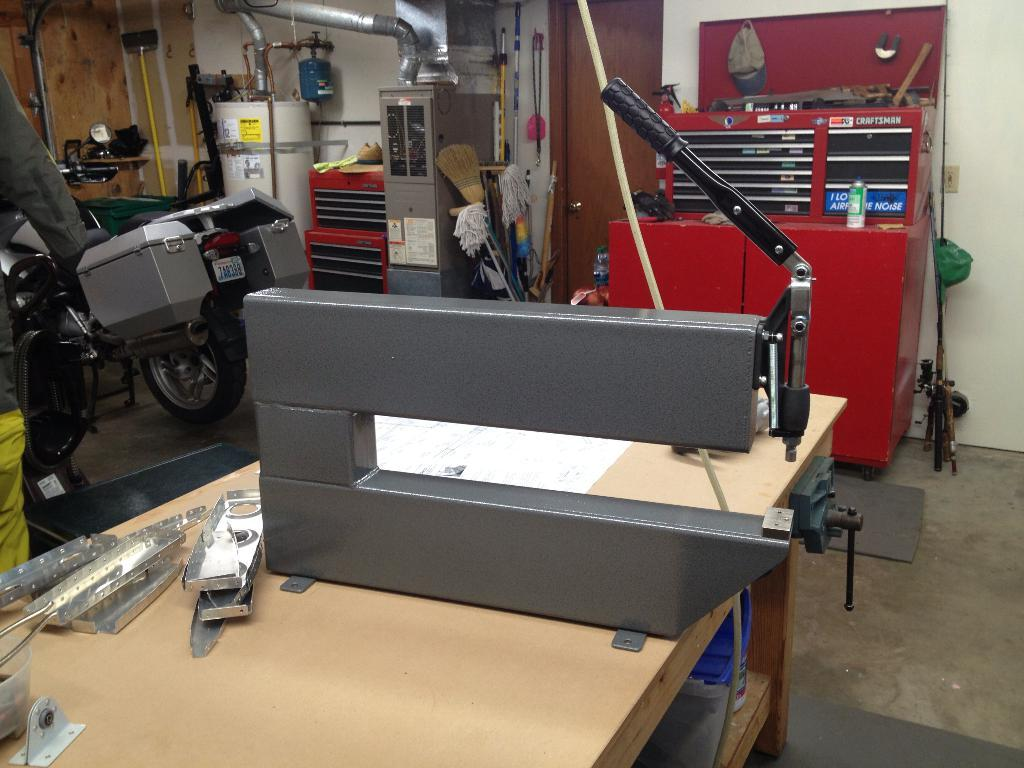What is the main object in the image? There is a table in the image. What is placed on the table? There is equipment on the table. What else can be seen in the image besides the table and equipment? There is a bike in the image. How many oranges are hanging from the bike in the image? There are no oranges present in the image, and therefore no such activity can be observed. 